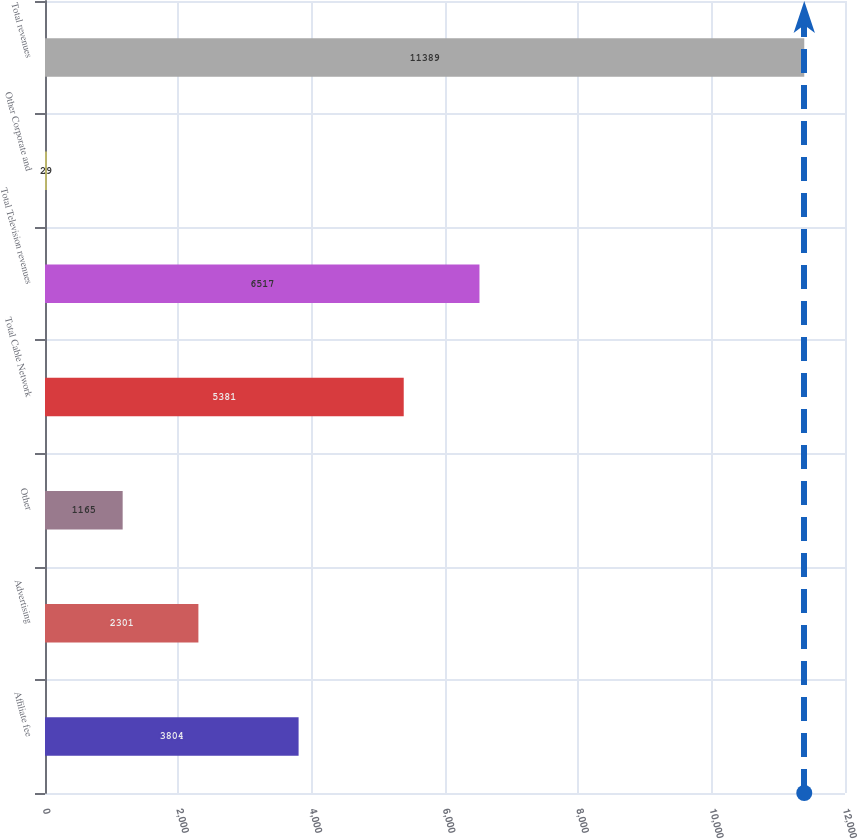Convert chart to OTSL. <chart><loc_0><loc_0><loc_500><loc_500><bar_chart><fcel>Affiliate fee<fcel>Advertising<fcel>Other<fcel>Total Cable Network<fcel>Total Television revenues<fcel>Other Corporate and<fcel>Total revenues<nl><fcel>3804<fcel>2301<fcel>1165<fcel>5381<fcel>6517<fcel>29<fcel>11389<nl></chart> 